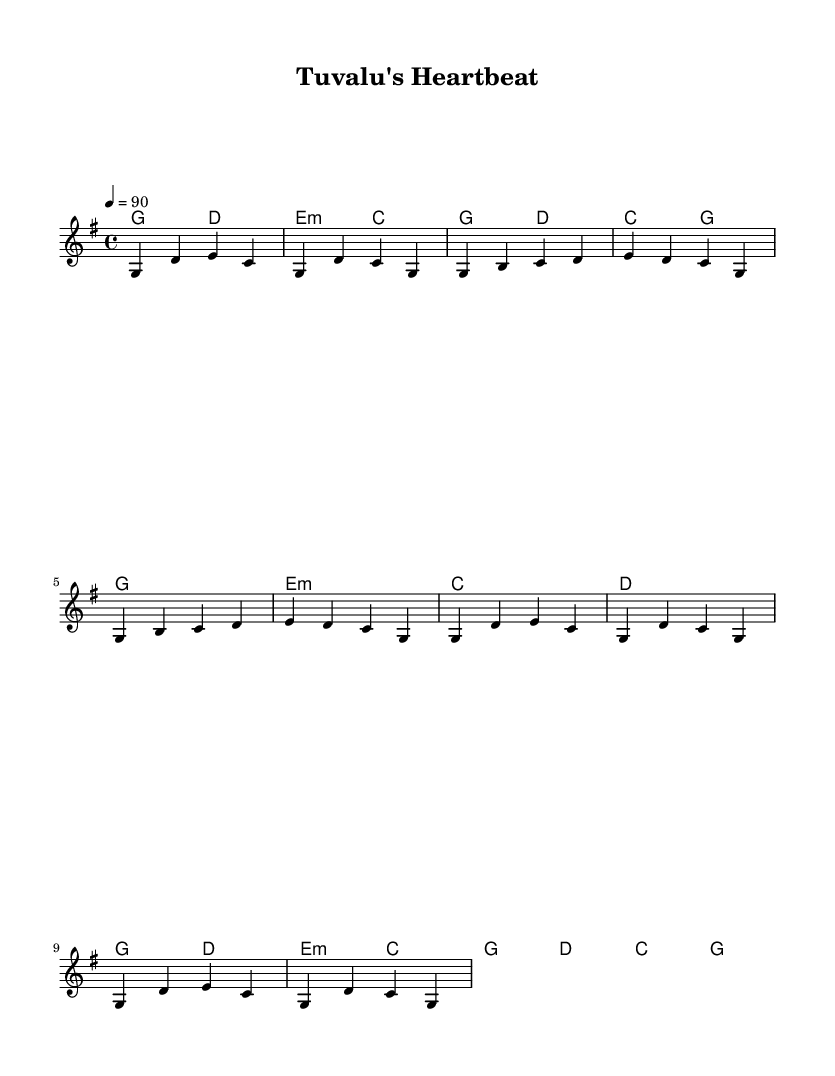What is the key signature of this music? The key signature is G major, which has one sharp (F#). This is indicated at the beginning of the staff with the sharp symbol on the F line.
Answer: G major What is the time signature of the piece? The time signature is 4/4, which means there are four beats in each bar and the quarter note gets one beat. This is shown at the beginning of the music as a fraction.
Answer: 4/4 What is the tempo of the piece? The tempo is indicated as 90 beats per minute (BPM), which means the piece should be played at that speed. This is stated above the staff as “4 = 90.”
Answer: 90 How many bars are in the chorus? The chorus consists of four bars, as counted from the staff where the chorus section is played. This can be seen by counting the measure lines in that specific section.
Answer: 4 What chord follows the first G major chord in the intro? The first G major chord in the intro is followed by a D major chord, which can be identified in the chord names section right after the G major.
Answer: D What is the last chord in the chorus? The last chord in the chorus is a G major chord, which can be determined by looking at the chord names and seeing what is written in the final measure of the chorus section.
Answer: G 